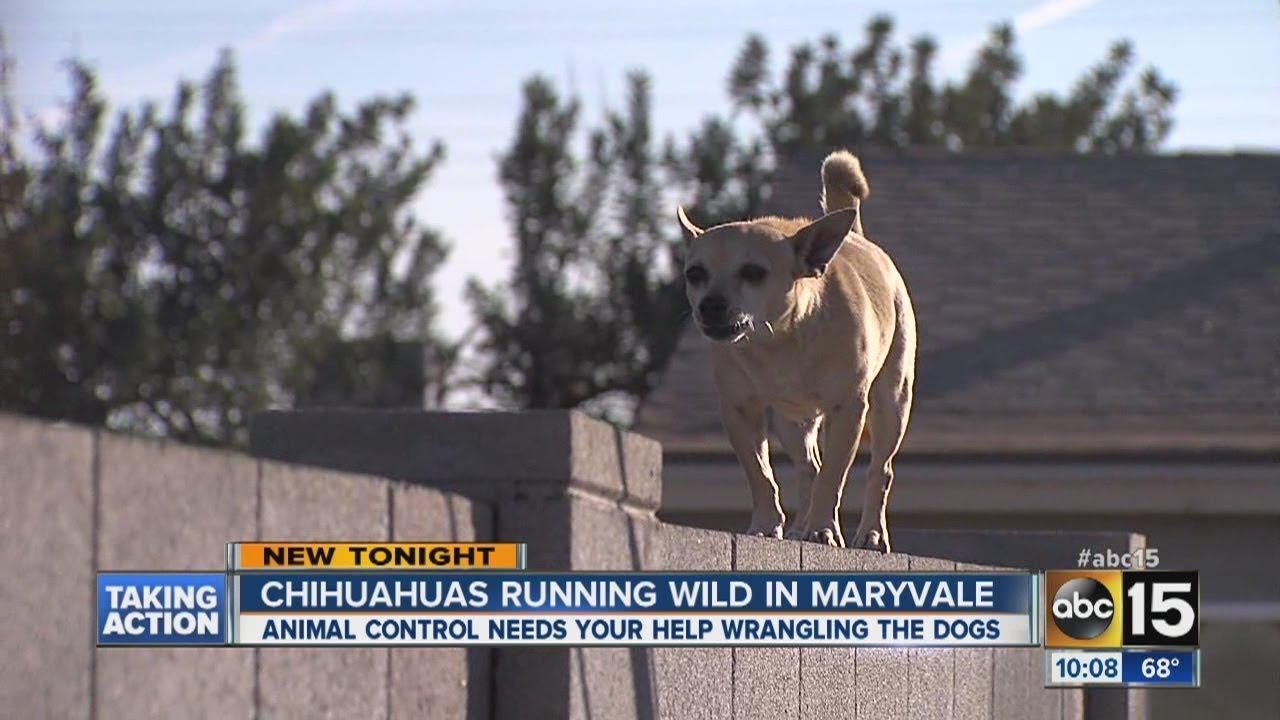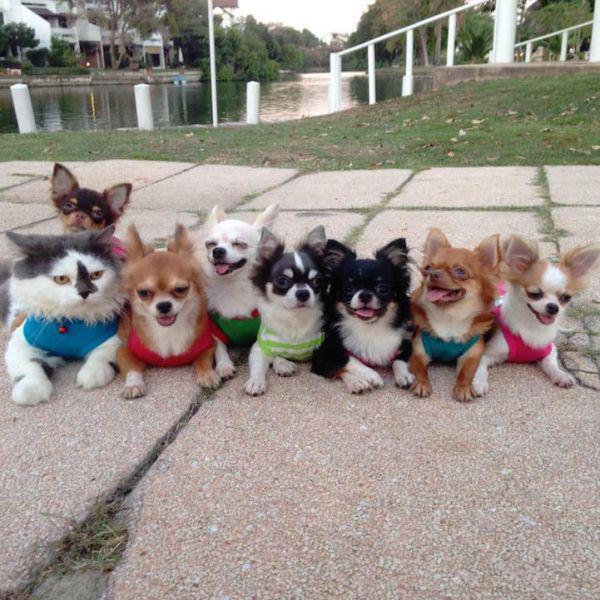The first image is the image on the left, the second image is the image on the right. Assess this claim about the two images: "The right image contains at least eight dogs.". Correct or not? Answer yes or no. Yes. The first image is the image on the left, the second image is the image on the right. Assess this claim about the two images: "A person walks toward the camera near a pack of small animals that walk on the same paved surface.". Correct or not? Answer yes or no. No. 